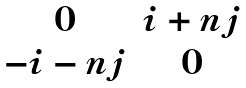Convert formula to latex. <formula><loc_0><loc_0><loc_500><loc_500>\begin{matrix} 0 & i + n j \\ - i - n j & 0 \end{matrix}</formula> 